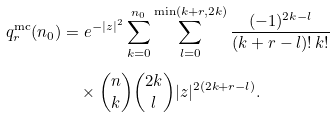Convert formula to latex. <formula><loc_0><loc_0><loc_500><loc_500>q ^ { \text {mc} } _ { r } ( n _ { 0 } ) & = e ^ { - | z | ^ { 2 } } \sum _ { k = 0 } ^ { n _ { 0 } } \sum _ { l = 0 } ^ { \min ( k + r , 2 k ) } \frac { ( - 1 ) ^ { 2 k - l } } { ( k + r - l ) ! \, k ! } \\ & \quad \times \binom { n } { k } \binom { 2 k } { l } | z | ^ { 2 ( 2 k + r - l ) } .</formula> 